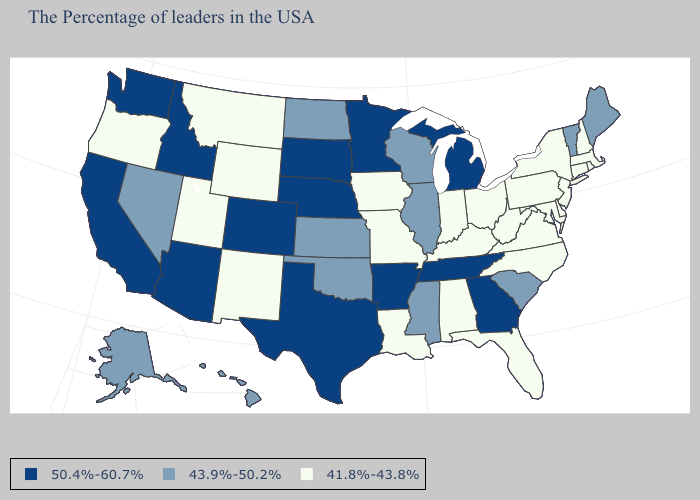Does the map have missing data?
Write a very short answer. No. What is the highest value in the MidWest ?
Short answer required. 50.4%-60.7%. Does Maryland have the highest value in the USA?
Write a very short answer. No. What is the value of Ohio?
Answer briefly. 41.8%-43.8%. What is the highest value in states that border Florida?
Give a very brief answer. 50.4%-60.7%. Among the states that border Oklahoma , does Missouri have the lowest value?
Quick response, please. Yes. What is the highest value in the MidWest ?
Be succinct. 50.4%-60.7%. Does Georgia have a lower value than Alaska?
Be succinct. No. Does Montana have the lowest value in the USA?
Give a very brief answer. Yes. What is the value of Alabama?
Give a very brief answer. 41.8%-43.8%. Does the map have missing data?
Be succinct. No. What is the value of Massachusetts?
Be succinct. 41.8%-43.8%. What is the value of Arizona?
Keep it brief. 50.4%-60.7%. How many symbols are there in the legend?
Answer briefly. 3. What is the lowest value in states that border Indiana?
Short answer required. 41.8%-43.8%. 